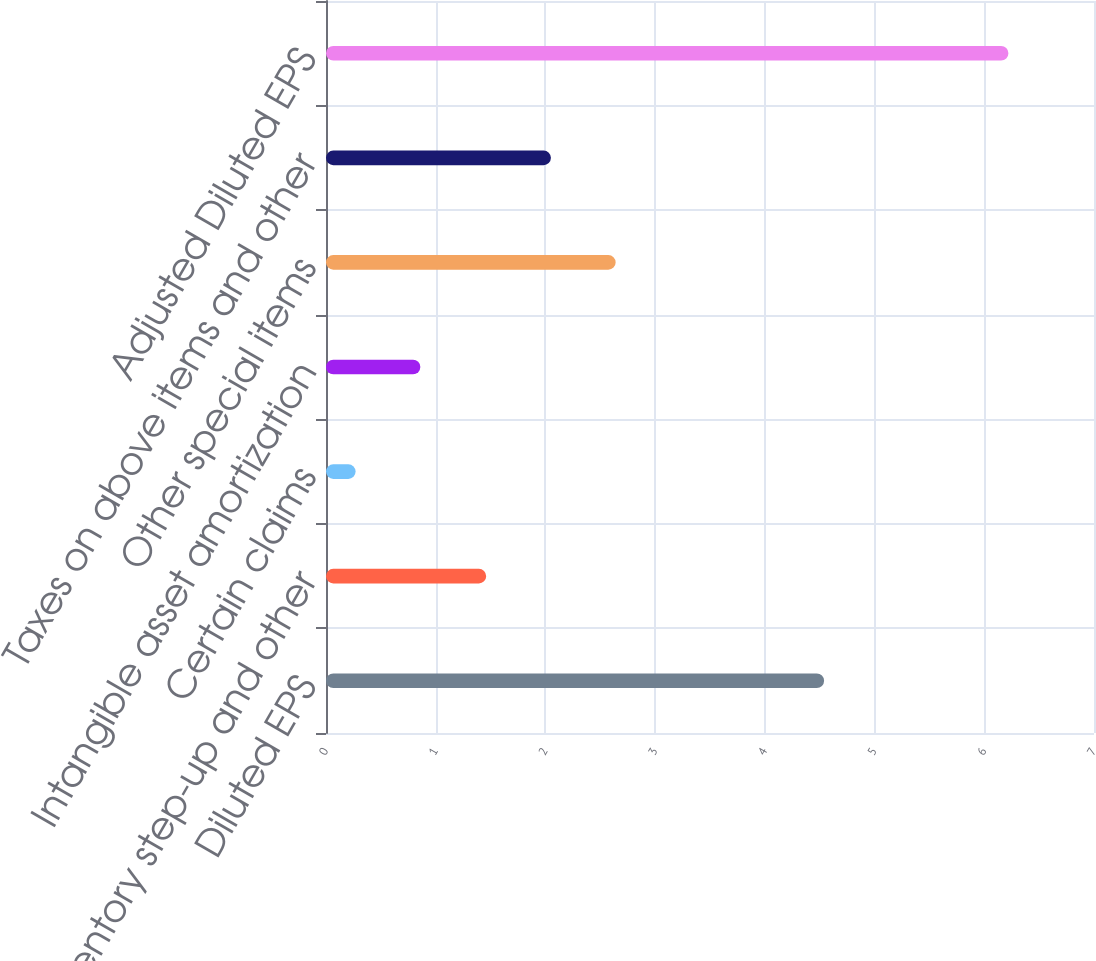<chart> <loc_0><loc_0><loc_500><loc_500><bar_chart><fcel>Diluted EPS<fcel>Inventory step-up and other<fcel>Certain claims<fcel>Intangible asset amortization<fcel>Other special items<fcel>Taxes on above items and other<fcel>Adjusted Diluted EPS<nl><fcel>4.54<fcel>1.46<fcel>0.27<fcel>0.86<fcel>2.64<fcel>2.05<fcel>6.22<nl></chart> 